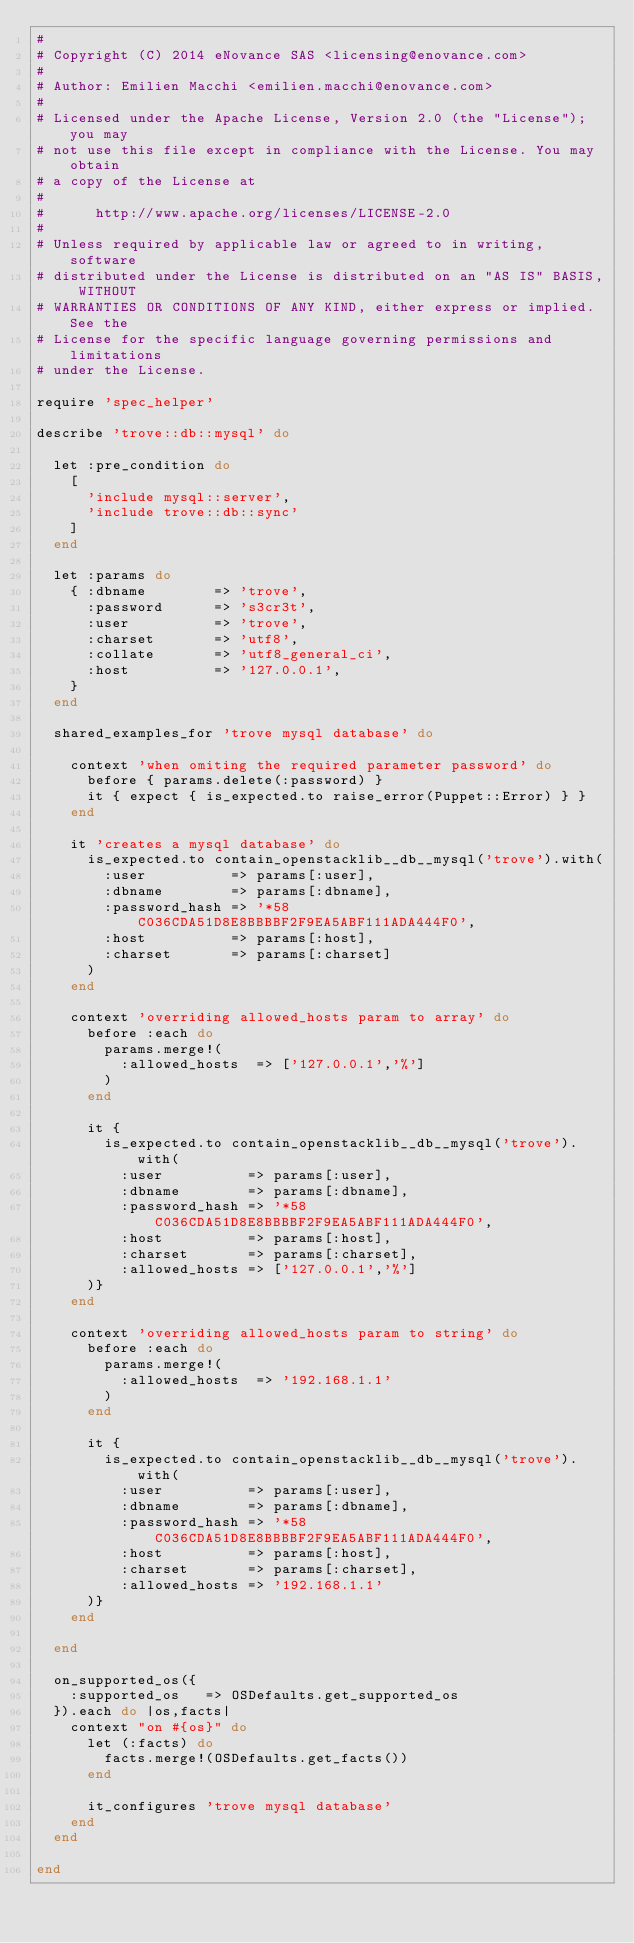<code> <loc_0><loc_0><loc_500><loc_500><_Ruby_>#
# Copyright (C) 2014 eNovance SAS <licensing@enovance.com>
#
# Author: Emilien Macchi <emilien.macchi@enovance.com>
#
# Licensed under the Apache License, Version 2.0 (the "License"); you may
# not use this file except in compliance with the License. You may obtain
# a copy of the License at
#
#      http://www.apache.org/licenses/LICENSE-2.0
#
# Unless required by applicable law or agreed to in writing, software
# distributed under the License is distributed on an "AS IS" BASIS, WITHOUT
# WARRANTIES OR CONDITIONS OF ANY KIND, either express or implied. See the
# License for the specific language governing permissions and limitations
# under the License.

require 'spec_helper'

describe 'trove::db::mysql' do

  let :pre_condition do
    [
      'include mysql::server',
      'include trove::db::sync'
    ]
  end

  let :params do
    { :dbname        => 'trove',
      :password      => 's3cr3t',
      :user          => 'trove',
      :charset       => 'utf8',
      :collate       => 'utf8_general_ci',
      :host          => '127.0.0.1',
    }
  end

  shared_examples_for 'trove mysql database' do

    context 'when omiting the required parameter password' do
      before { params.delete(:password) }
      it { expect { is_expected.to raise_error(Puppet::Error) } }
    end

    it 'creates a mysql database' do
      is_expected.to contain_openstacklib__db__mysql('trove').with(
        :user          => params[:user],
        :dbname        => params[:dbname],
        :password_hash => '*58C036CDA51D8E8BBBBF2F9EA5ABF111ADA444F0',
        :host          => params[:host],
        :charset       => params[:charset]
      )
    end

    context 'overriding allowed_hosts param to array' do
      before :each do
        params.merge!(
          :allowed_hosts  => ['127.0.0.1','%']
        )
      end

      it {
        is_expected.to contain_openstacklib__db__mysql('trove').with(
          :user          => params[:user],
          :dbname        => params[:dbname],
          :password_hash => '*58C036CDA51D8E8BBBBF2F9EA5ABF111ADA444F0',
          :host          => params[:host],
          :charset       => params[:charset],
          :allowed_hosts => ['127.0.0.1','%']
      )}
    end

    context 'overriding allowed_hosts param to string' do
      before :each do
        params.merge!(
          :allowed_hosts  => '192.168.1.1'
        )
      end

      it {
        is_expected.to contain_openstacklib__db__mysql('trove').with(
          :user          => params[:user],
          :dbname        => params[:dbname],
          :password_hash => '*58C036CDA51D8E8BBBBF2F9EA5ABF111ADA444F0',
          :host          => params[:host],
          :charset       => params[:charset],
          :allowed_hosts => '192.168.1.1'
      )}
    end

  end

  on_supported_os({
    :supported_os   => OSDefaults.get_supported_os
  }).each do |os,facts|
    context "on #{os}" do
      let (:facts) do
        facts.merge!(OSDefaults.get_facts())
      end

      it_configures 'trove mysql database'
    end
  end

end
</code> 